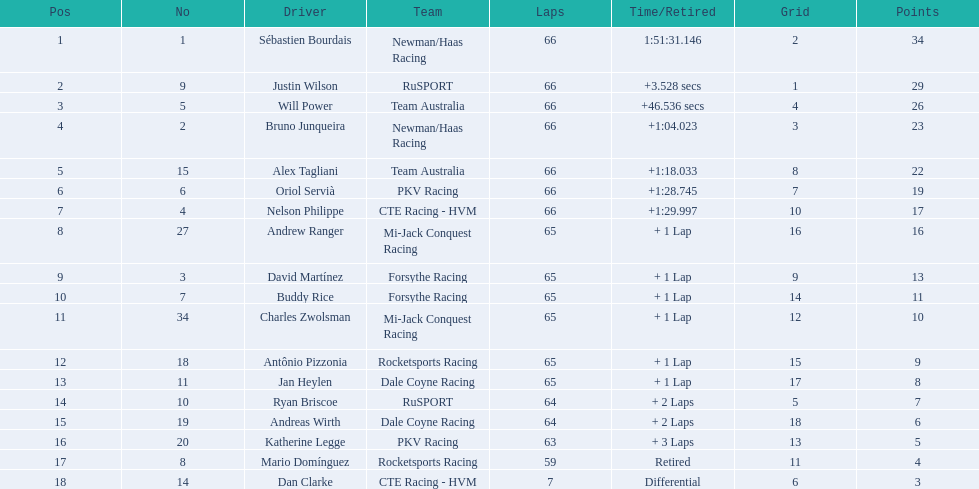Which people scored 29+ points? Sébastien Bourdais, Justin Wilson. Who scored higher? Sébastien Bourdais. 